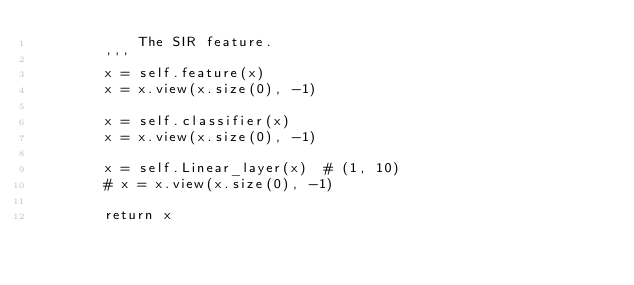Convert code to text. <code><loc_0><loc_0><loc_500><loc_500><_Python_>            The SIR feature.
        '''
        x = self.feature(x)
        x = x.view(x.size(0), -1)

        x = self.classifier(x)
        x = x.view(x.size(0), -1)

        x = self.Linear_layer(x)  # (1, 10)
        # x = x.view(x.size(0), -1)

        return x
</code> 